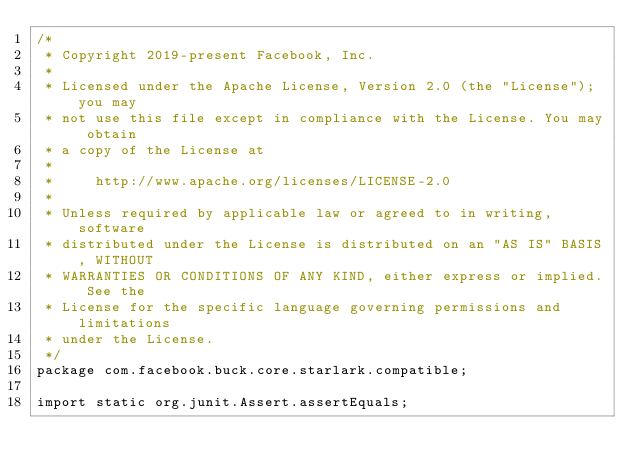Convert code to text. <code><loc_0><loc_0><loc_500><loc_500><_Java_>/*
 * Copyright 2019-present Facebook, Inc.
 *
 * Licensed under the Apache License, Version 2.0 (the "License"); you may
 * not use this file except in compliance with the License. You may obtain
 * a copy of the License at
 *
 *     http://www.apache.org/licenses/LICENSE-2.0
 *
 * Unless required by applicable law or agreed to in writing, software
 * distributed under the License is distributed on an "AS IS" BASIS, WITHOUT
 * WARRANTIES OR CONDITIONS OF ANY KIND, either express or implied. See the
 * License for the specific language governing permissions and limitations
 * under the License.
 */
package com.facebook.buck.core.starlark.compatible;

import static org.junit.Assert.assertEquals;
</code> 